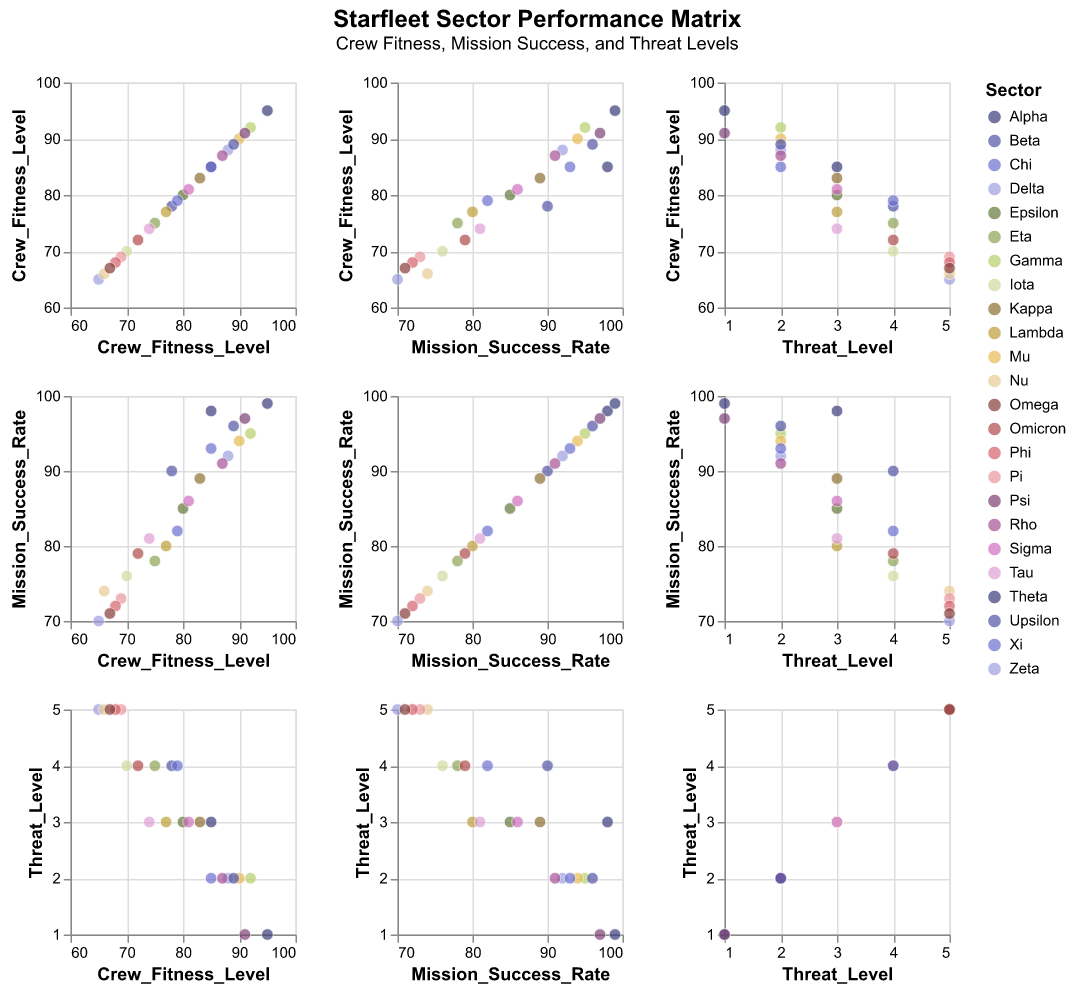Which sector has the highest crew fitness level? Look for the data point with the highest value on the Crew Fitness Level axis. The highest value is 95, belonging to "Theta".
Answer: Theta How many sectors have a crew fitness level above 90? Count all the data points that lie above 90 on the Crew Fitness Level axis. The sectors are Gamma, Theta, Mu, Psi, and Upsilon, making a total of 5.
Answer: 5 Which sectors have the same Threat Level? Identify sectors with overlapping points on the Threat Level axis. For Threat Level 1: Theta and Psi. For Threat Level 2: Gamma, Zeta, Mu, Xi, Rho, and Upsilon. For Threat Level 3: Alpha, Epsilon, Kappa, Lambda, Sigma, and Tau. For Threat Level 4: Beta, Eta, Iota, Omicron, and Chi. For Threat Level 5: Delta, Nu, Pi, Phi, and Omega.
Answer: Theta and Psi; Gamma, Zeta, Mu, Xi, Rho, Upsilon; Alpha, Epsilon, Kappa, Lambda, Sigma, Tau; Beta, Eta, Iota, Omicron, Chi; Delta, Nu, Pi, Phi, Omega Which sectors show a mission success rate below 75%? Look for data points below 75 on the Mission Success Rate axis. The sectors are Delta, Iota, Nu, Pi, Phi, and Omega.
Answer: Delta, Iota, Nu, Pi, Phi, Omega Is there a correlation between crew fitness level and mission success rate? Look at the pattern formed by data points in the Crew Fitness Level vs. Mission Success Rate subplot. The data points appear to form a trend that suggests higher fitness levels correlate with higher mission success rates.
Answer: Yes Which sector encountered the lowest threat level and what is their mission success rate? Find the data point at the lowest Threat Level of 1. Theta and Psi both have Threat Level 1. Theta has a mission success rate of 99%, and Psi has a mission success rate of 97%.
Answer: Theta: 99%; Psi: 97% What is the average mission success rate for sectors with a threat level of 4? Identify sectors with Threat Level 4 and average their mission success rates. The sectors are Beta (90), Eta (78), Iota (76), Omicron (79), and Chi (82). Calculate the average: (90 + 78 + 76 + 79 + 82) / 5 = 81.
Answer: 81 Which sector has the lowest crew fitness level? Identify the data point with the lowest value on the Crew Fitness Level axis. The lowest value is 65, belonging to "Delta".
Answer: Delta How many sectors have a threat level of 2? Count all the data points that lie on the 2 position on the Threat Level axis. The sectors are Gamma, Zeta, Mu, Xi, Rho, and Upsilon, making a total of 6.
Answer: 6 If we consider sectors with mission success rates above 90%, what is their range of Threat Levels? Identify sectors with Mission Success Rates above 90, then note their corresponding Threat Levels. Those sectors are Alpha (3), Beta (4), Gamma (2), Theta (1), Mu (2), Upsilon (2), and Psi (1). The Threat Levels range from 1 to 4.
Answer: 1 to 4 